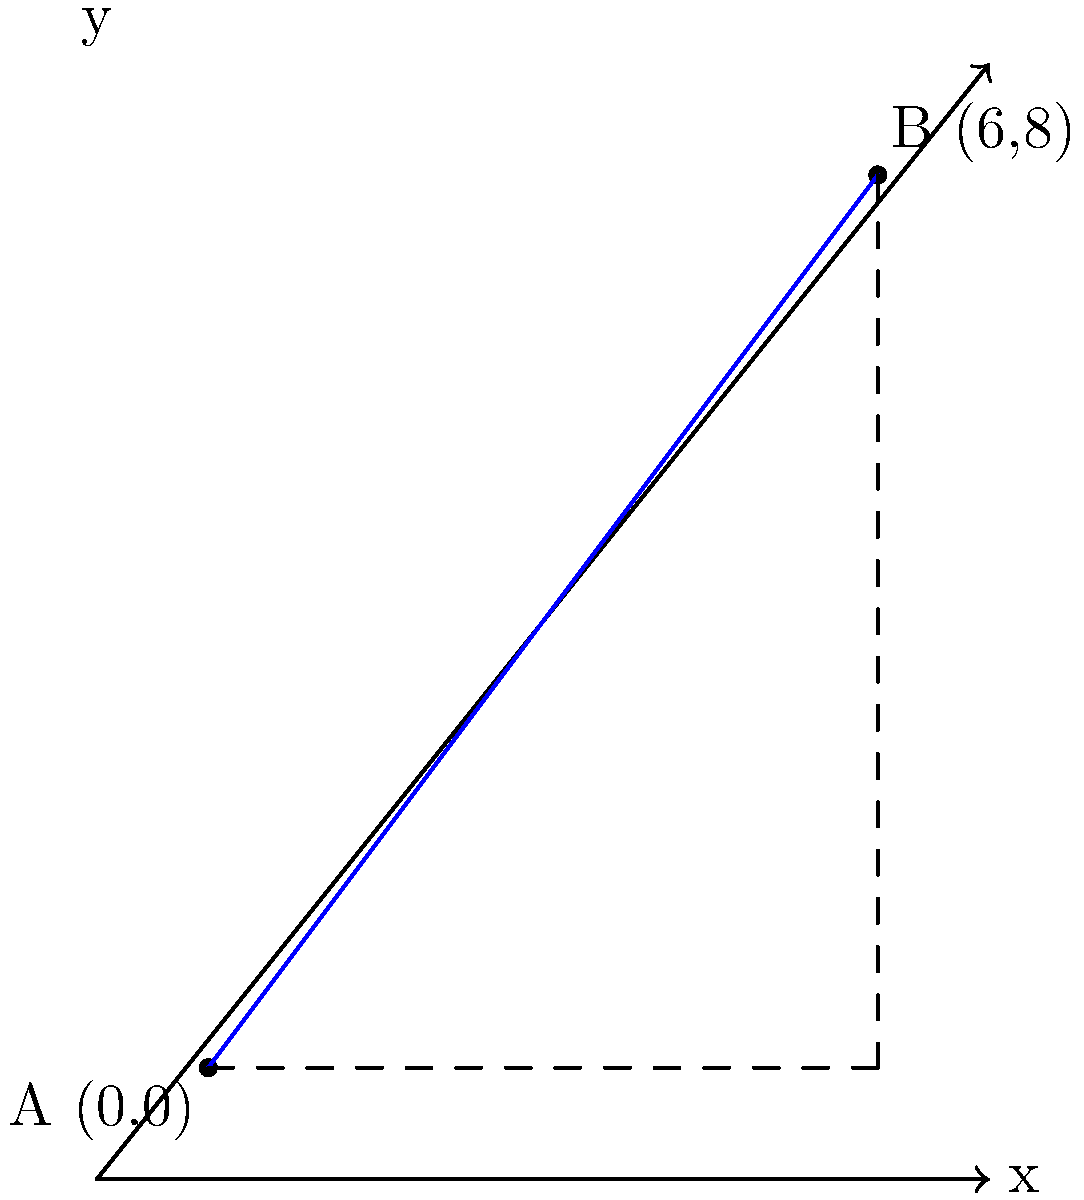You're planning a surf trip and want to know the distance between two beaches. Beach A is located at coordinates (0,0) and Beach B is at (6,8) on your map. Using the Cartesian coordinate system, calculate the straight-line distance between these two surf spots. To find the distance between two points in a Cartesian coordinate system, we can use the distance formula, which is derived from the Pythagorean theorem:

$$ d = \sqrt{(x_2 - x_1)^2 + (y_2 - y_1)^2} $$

Where $(x_1, y_1)$ are the coordinates of the first point and $(x_2, y_2)$ are the coordinates of the second point.

Given:
- Beach A: $(x_1, y_1) = (0, 0)$
- Beach B: $(x_2, y_2) = (6, 8)$

Let's plug these values into the formula:

$$ d = \sqrt{(6 - 0)^2 + (8 - 0)^2} $$

Simplify:
$$ d = \sqrt{6^2 + 8^2} $$

Calculate the squares:
$$ d = \sqrt{36 + 64} $$

Add under the square root:
$$ d = \sqrt{100} $$

Simplify:
$$ d = 10 $$

Therefore, the distance between Beach A and Beach B is 10 units on your map.
Answer: 10 units 